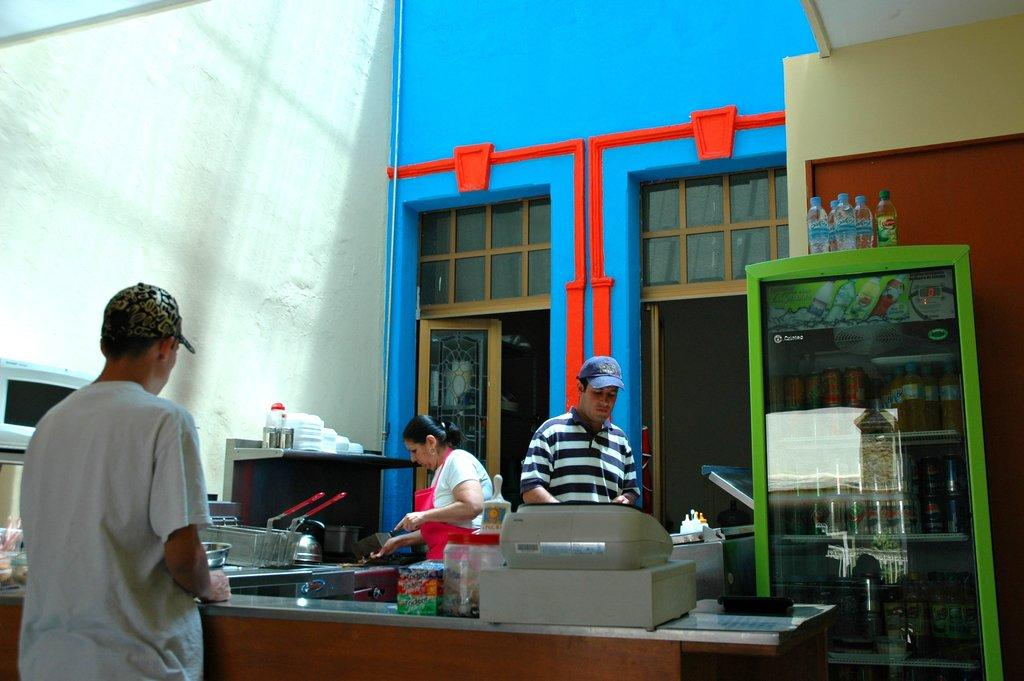How many people are present in the image? There are three persons in the image. What are the persons doing in the image? The persons are working in a kitchen. What appliance can be seen on the right side of the image? There is a fridge on the right side of the image. What type of finger food is being prepared by the persons in the image? There is no indication of any finger food being prepared in the image. How does the girl feel about the kitchen work in the image? There is no girl present in the image, so it is not possible to determine her feelings about the kitchen work. 